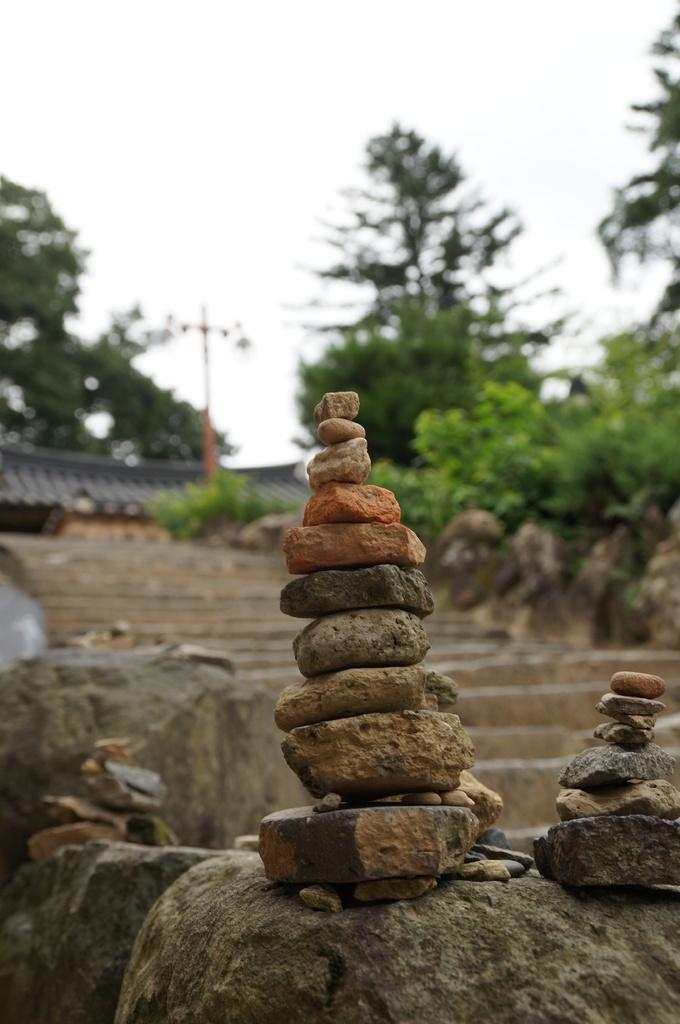What can be seen in the foreground of the image? In the foreground of the image, there are stones, a staircase, and a fence. What is visible in the background of the image? In the background of the image, there are trees, houses, and poles. What is the condition of the sky in the image? The sky is visible at the top of the image, and it was taken during the day. Can you find the receipt for the zoo visit in the image? There is no receipt or zoo visit mentioned in the image. What type of joke is being told by the fence in the image? There is no joke being told by the fence in the image; it is a stationary object. 